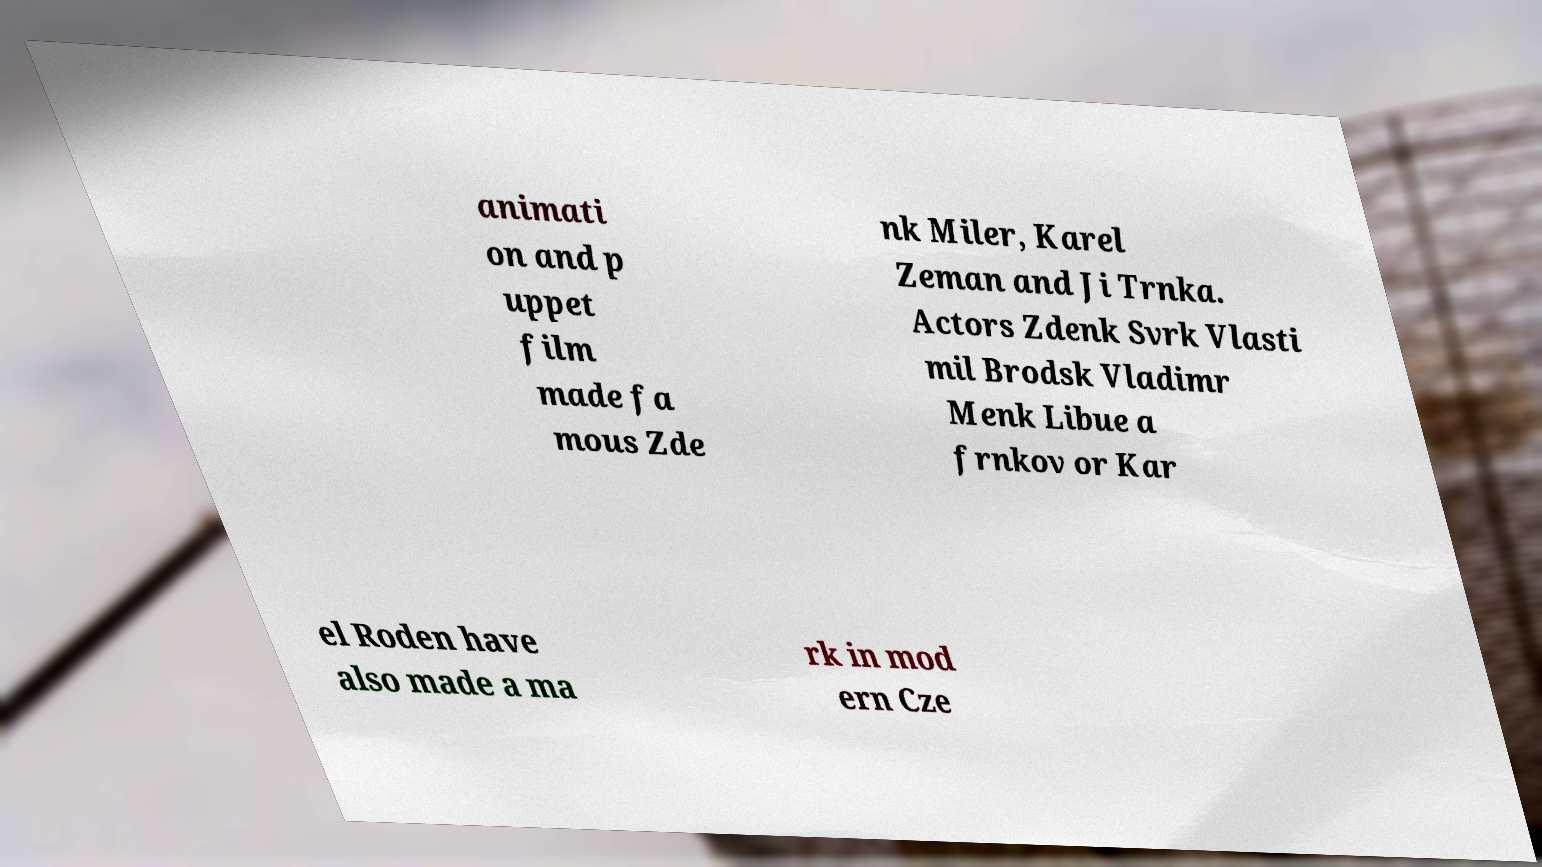Can you read and provide the text displayed in the image?This photo seems to have some interesting text. Can you extract and type it out for me? animati on and p uppet film made fa mous Zde nk Miler, Karel Zeman and Ji Trnka. Actors Zdenk Svrk Vlasti mil Brodsk Vladimr Menk Libue a frnkov or Kar el Roden have also made a ma rk in mod ern Cze 